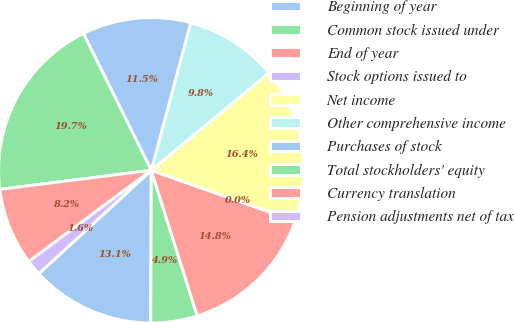<chart> <loc_0><loc_0><loc_500><loc_500><pie_chart><fcel>Beginning of year<fcel>Common stock issued under<fcel>End of year<fcel>Stock options issued to<fcel>Net income<fcel>Other comprehensive income<fcel>Purchases of stock<fcel>Total stockholders' equity<fcel>Currency translation<fcel>Pension adjustments net of tax<nl><fcel>13.11%<fcel>4.92%<fcel>14.75%<fcel>0.0%<fcel>16.39%<fcel>9.84%<fcel>11.48%<fcel>19.67%<fcel>8.2%<fcel>1.64%<nl></chart> 